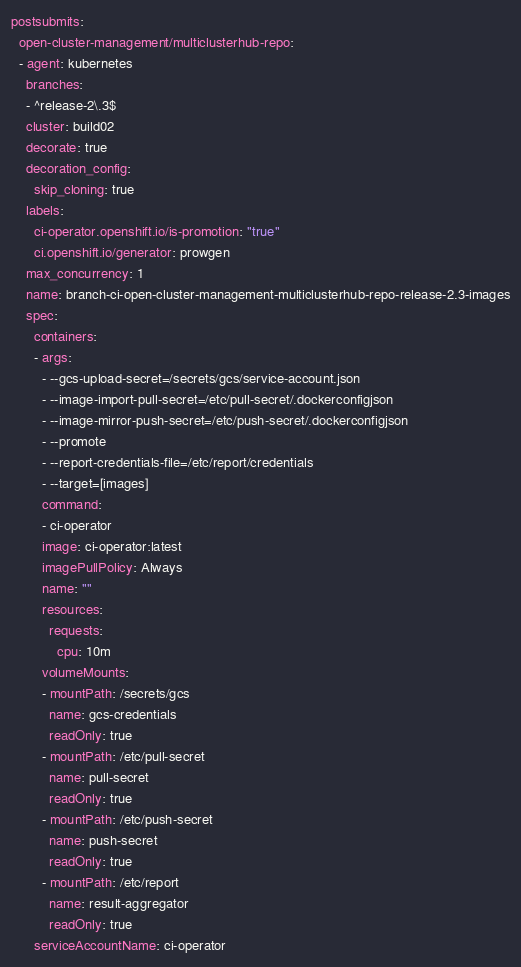<code> <loc_0><loc_0><loc_500><loc_500><_YAML_>postsubmits:
  open-cluster-management/multiclusterhub-repo:
  - agent: kubernetes
    branches:
    - ^release-2\.3$
    cluster: build02
    decorate: true
    decoration_config:
      skip_cloning: true
    labels:
      ci-operator.openshift.io/is-promotion: "true"
      ci.openshift.io/generator: prowgen
    max_concurrency: 1
    name: branch-ci-open-cluster-management-multiclusterhub-repo-release-2.3-images
    spec:
      containers:
      - args:
        - --gcs-upload-secret=/secrets/gcs/service-account.json
        - --image-import-pull-secret=/etc/pull-secret/.dockerconfigjson
        - --image-mirror-push-secret=/etc/push-secret/.dockerconfigjson
        - --promote
        - --report-credentials-file=/etc/report/credentials
        - --target=[images]
        command:
        - ci-operator
        image: ci-operator:latest
        imagePullPolicy: Always
        name: ""
        resources:
          requests:
            cpu: 10m
        volumeMounts:
        - mountPath: /secrets/gcs
          name: gcs-credentials
          readOnly: true
        - mountPath: /etc/pull-secret
          name: pull-secret
          readOnly: true
        - mountPath: /etc/push-secret
          name: push-secret
          readOnly: true
        - mountPath: /etc/report
          name: result-aggregator
          readOnly: true
      serviceAccountName: ci-operator</code> 